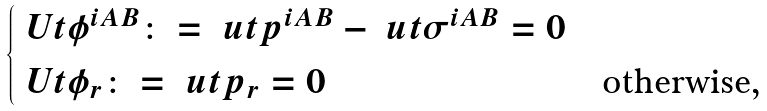<formula> <loc_0><loc_0><loc_500><loc_500>\begin{cases} \ U t { \phi } ^ { i A B } \colon = \ u t { p } ^ { i A B } - \ u t { \sigma } ^ { i A B } = 0 & \\ \ U t { \phi } _ { r } \colon = \ u t { p } _ { r } = 0 & \text {otherwise,} \end{cases}</formula> 